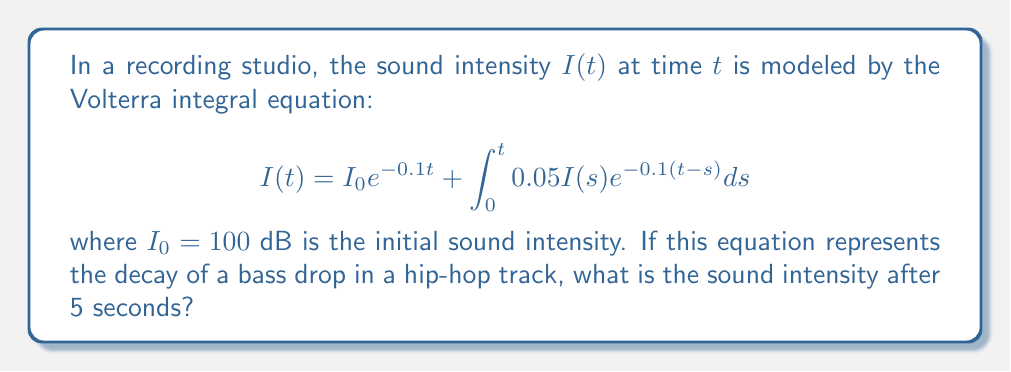Show me your answer to this math problem. Let's approach this step-by-step:

1) First, we need to recognize that this is a linear Volterra integral equation of the second kind. The general form is:

   $$I(t) = f(t) + \int_0^t K(t,s)I(s)ds$$

   where $f(t) = I_0 e^{-0.1t}$ and $K(t,s) = 0.05 e^{-0.1(t-s)}$

2) For linear Volterra equations, we can use the method of successive approximations. Let's start with $I_0(t) = f(t)$:

   $$I_0(t) = 100 e^{-0.1t}$$

3) Now, we iterate:

   $$I_1(t) = 100 e^{-0.1t} + \int_0^t 0.05 (100 e^{-0.1s}) e^{-0.1(t-s)} ds$$

4) Simplifying the integral:

   $$I_1(t) = 100 e^{-0.1t} + 5 \int_0^t e^{-0.1t} ds = 100 e^{-0.1t} + 5t e^{-0.1t}$$

5) We could continue this process, but for practical purposes, $I_1(t)$ is often a good approximation.

6) Now, we evaluate $I_1(5)$:

   $$I_1(5) = 100 e^{-0.5} + 5 \cdot 5 e^{-0.5} = 100 \cdot 0.6065 + 25 \cdot 0.6065 = 75.81$$

Therefore, after 5 seconds, the sound intensity is approximately 75.81 dB.
Answer: 75.81 dB 